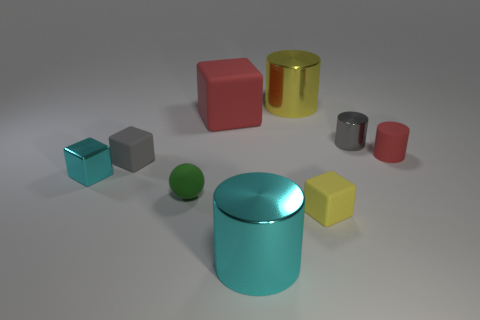How many green things are either shiny cylinders or small balls?
Provide a succinct answer. 1. How many large cylinders are the same color as the ball?
Your answer should be compact. 0. Does the big cyan thing have the same material as the small sphere?
Give a very brief answer. No. What number of blocks are to the left of the red matte thing that is behind the small metal cylinder?
Provide a succinct answer. 2. Is the size of the cyan cube the same as the green sphere?
Keep it short and to the point. Yes. What number of tiny cylinders have the same material as the small cyan block?
Provide a short and direct response. 1. There is a cyan shiny object that is the same shape as the yellow rubber thing; what size is it?
Give a very brief answer. Small. There is a red rubber thing to the left of the tiny red cylinder; does it have the same shape as the yellow rubber object?
Offer a very short reply. Yes. There is a shiny thing that is in front of the small cube that is to the left of the small gray rubber thing; what is its shape?
Your answer should be very brief. Cylinder. Is there any other thing that has the same shape as the small green rubber thing?
Provide a short and direct response. No. 